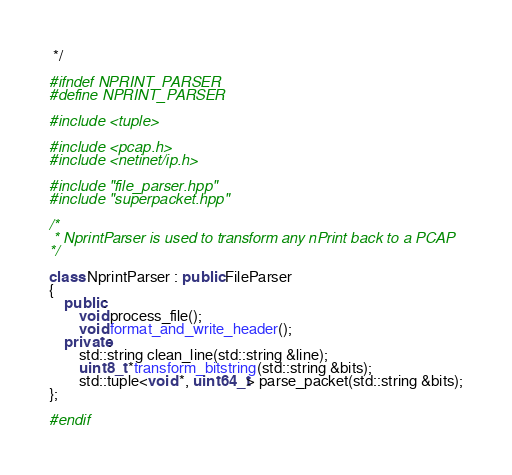Convert code to text. <code><loc_0><loc_0><loc_500><loc_500><_C++_> */

#ifndef NPRINT_PARSER 
#define NPRINT_PARSER

#include <tuple> 

#include <pcap.h>
#include <netinet/ip.h>

#include "file_parser.hpp"
#include "superpacket.hpp"

/* 
 * NprintParser is used to transform any nPrint back to a PCAP
*/

class NprintParser : public FileParser
{
    public: 
        void process_file();
        void format_and_write_header();
    private:
        std::string clean_line(std::string &line);
        uint8_t *transform_bitstring(std::string &bits);
        std::tuple<void *, uint64_t> parse_packet(std::string &bits);
};

#endif
</code> 